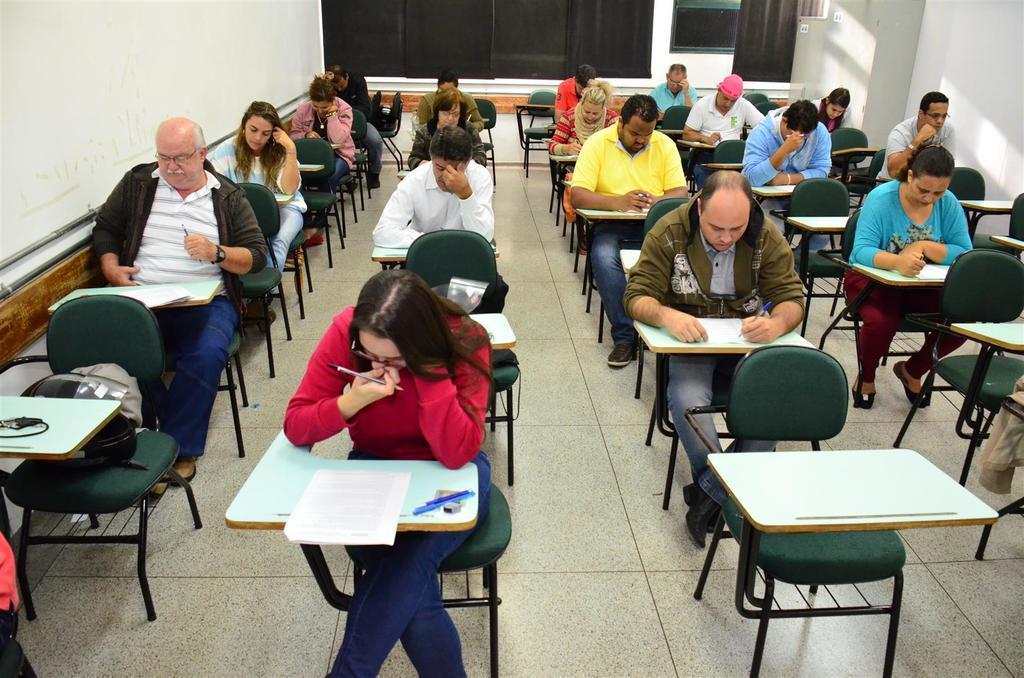Please provide a concise description of this image. In this image I can see the group of people sitting in front of the table. On the table there is a paper and the pens. To the left there is a helmet on the chair. To the side of these people there is a wall. 